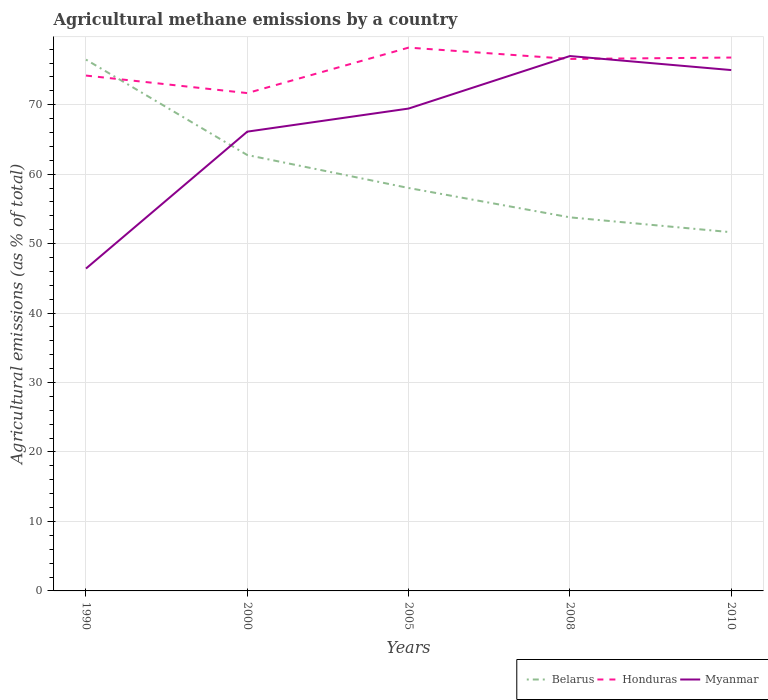Does the line corresponding to Honduras intersect with the line corresponding to Myanmar?
Provide a succinct answer. Yes. Is the number of lines equal to the number of legend labels?
Provide a short and direct response. Yes. Across all years, what is the maximum amount of agricultural methane emitted in Belarus?
Your answer should be very brief. 51.64. What is the total amount of agricultural methane emitted in Honduras in the graph?
Your answer should be very brief. 1.63. What is the difference between the highest and the second highest amount of agricultural methane emitted in Myanmar?
Your answer should be compact. 30.59. What is the difference between the highest and the lowest amount of agricultural methane emitted in Myanmar?
Your answer should be very brief. 3. Is the amount of agricultural methane emitted in Myanmar strictly greater than the amount of agricultural methane emitted in Belarus over the years?
Ensure brevity in your answer.  No. What is the difference between two consecutive major ticks on the Y-axis?
Make the answer very short. 10. Are the values on the major ticks of Y-axis written in scientific E-notation?
Provide a short and direct response. No. Does the graph contain any zero values?
Ensure brevity in your answer.  No. Does the graph contain grids?
Your response must be concise. Yes. How many legend labels are there?
Keep it short and to the point. 3. What is the title of the graph?
Keep it short and to the point. Agricultural methane emissions by a country. Does "Antigua and Barbuda" appear as one of the legend labels in the graph?
Keep it short and to the point. No. What is the label or title of the Y-axis?
Your answer should be very brief. Agricultural emissions (as % of total). What is the Agricultural emissions (as % of total) of Belarus in 1990?
Ensure brevity in your answer.  76.49. What is the Agricultural emissions (as % of total) in Honduras in 1990?
Make the answer very short. 74.19. What is the Agricultural emissions (as % of total) of Myanmar in 1990?
Give a very brief answer. 46.41. What is the Agricultural emissions (as % of total) in Belarus in 2000?
Your answer should be compact. 62.75. What is the Agricultural emissions (as % of total) in Honduras in 2000?
Give a very brief answer. 71.67. What is the Agricultural emissions (as % of total) of Myanmar in 2000?
Your answer should be very brief. 66.12. What is the Agricultural emissions (as % of total) in Belarus in 2005?
Offer a very short reply. 58.01. What is the Agricultural emissions (as % of total) of Honduras in 2005?
Your response must be concise. 78.21. What is the Agricultural emissions (as % of total) in Myanmar in 2005?
Provide a succinct answer. 69.44. What is the Agricultural emissions (as % of total) of Belarus in 2008?
Give a very brief answer. 53.78. What is the Agricultural emissions (as % of total) of Honduras in 2008?
Your answer should be compact. 76.58. What is the Agricultural emissions (as % of total) in Myanmar in 2008?
Ensure brevity in your answer.  77. What is the Agricultural emissions (as % of total) of Belarus in 2010?
Offer a very short reply. 51.64. What is the Agricultural emissions (as % of total) of Honduras in 2010?
Offer a terse response. 76.78. What is the Agricultural emissions (as % of total) in Myanmar in 2010?
Provide a succinct answer. 74.98. Across all years, what is the maximum Agricultural emissions (as % of total) of Belarus?
Offer a terse response. 76.49. Across all years, what is the maximum Agricultural emissions (as % of total) of Honduras?
Your response must be concise. 78.21. Across all years, what is the maximum Agricultural emissions (as % of total) in Myanmar?
Provide a succinct answer. 77. Across all years, what is the minimum Agricultural emissions (as % of total) of Belarus?
Your response must be concise. 51.64. Across all years, what is the minimum Agricultural emissions (as % of total) of Honduras?
Give a very brief answer. 71.67. Across all years, what is the minimum Agricultural emissions (as % of total) of Myanmar?
Your answer should be very brief. 46.41. What is the total Agricultural emissions (as % of total) in Belarus in the graph?
Your answer should be compact. 302.66. What is the total Agricultural emissions (as % of total) of Honduras in the graph?
Your answer should be compact. 377.44. What is the total Agricultural emissions (as % of total) of Myanmar in the graph?
Give a very brief answer. 333.95. What is the difference between the Agricultural emissions (as % of total) of Belarus in 1990 and that in 2000?
Offer a terse response. 13.74. What is the difference between the Agricultural emissions (as % of total) of Honduras in 1990 and that in 2000?
Ensure brevity in your answer.  2.52. What is the difference between the Agricultural emissions (as % of total) of Myanmar in 1990 and that in 2000?
Your response must be concise. -19.71. What is the difference between the Agricultural emissions (as % of total) in Belarus in 1990 and that in 2005?
Keep it short and to the point. 18.48. What is the difference between the Agricultural emissions (as % of total) in Honduras in 1990 and that in 2005?
Keep it short and to the point. -4.02. What is the difference between the Agricultural emissions (as % of total) of Myanmar in 1990 and that in 2005?
Provide a succinct answer. -23.03. What is the difference between the Agricultural emissions (as % of total) of Belarus in 1990 and that in 2008?
Ensure brevity in your answer.  22.71. What is the difference between the Agricultural emissions (as % of total) of Honduras in 1990 and that in 2008?
Offer a very short reply. -2.39. What is the difference between the Agricultural emissions (as % of total) of Myanmar in 1990 and that in 2008?
Your answer should be very brief. -30.59. What is the difference between the Agricultural emissions (as % of total) in Belarus in 1990 and that in 2010?
Keep it short and to the point. 24.85. What is the difference between the Agricultural emissions (as % of total) of Honduras in 1990 and that in 2010?
Your answer should be very brief. -2.59. What is the difference between the Agricultural emissions (as % of total) of Myanmar in 1990 and that in 2010?
Offer a very short reply. -28.57. What is the difference between the Agricultural emissions (as % of total) of Belarus in 2000 and that in 2005?
Your response must be concise. 4.74. What is the difference between the Agricultural emissions (as % of total) of Honduras in 2000 and that in 2005?
Provide a succinct answer. -6.55. What is the difference between the Agricultural emissions (as % of total) of Myanmar in 2000 and that in 2005?
Ensure brevity in your answer.  -3.32. What is the difference between the Agricultural emissions (as % of total) in Belarus in 2000 and that in 2008?
Provide a short and direct response. 8.97. What is the difference between the Agricultural emissions (as % of total) in Honduras in 2000 and that in 2008?
Your response must be concise. -4.92. What is the difference between the Agricultural emissions (as % of total) in Myanmar in 2000 and that in 2008?
Your answer should be very brief. -10.88. What is the difference between the Agricultural emissions (as % of total) of Belarus in 2000 and that in 2010?
Give a very brief answer. 11.11. What is the difference between the Agricultural emissions (as % of total) of Honduras in 2000 and that in 2010?
Make the answer very short. -5.12. What is the difference between the Agricultural emissions (as % of total) of Myanmar in 2000 and that in 2010?
Make the answer very short. -8.86. What is the difference between the Agricultural emissions (as % of total) in Belarus in 2005 and that in 2008?
Your answer should be compact. 4.23. What is the difference between the Agricultural emissions (as % of total) of Honduras in 2005 and that in 2008?
Keep it short and to the point. 1.63. What is the difference between the Agricultural emissions (as % of total) in Myanmar in 2005 and that in 2008?
Provide a succinct answer. -7.56. What is the difference between the Agricultural emissions (as % of total) of Belarus in 2005 and that in 2010?
Ensure brevity in your answer.  6.37. What is the difference between the Agricultural emissions (as % of total) of Honduras in 2005 and that in 2010?
Provide a short and direct response. 1.43. What is the difference between the Agricultural emissions (as % of total) of Myanmar in 2005 and that in 2010?
Offer a terse response. -5.54. What is the difference between the Agricultural emissions (as % of total) in Belarus in 2008 and that in 2010?
Ensure brevity in your answer.  2.14. What is the difference between the Agricultural emissions (as % of total) of Honduras in 2008 and that in 2010?
Offer a very short reply. -0.2. What is the difference between the Agricultural emissions (as % of total) of Myanmar in 2008 and that in 2010?
Offer a terse response. 2.02. What is the difference between the Agricultural emissions (as % of total) in Belarus in 1990 and the Agricultural emissions (as % of total) in Honduras in 2000?
Keep it short and to the point. 4.82. What is the difference between the Agricultural emissions (as % of total) in Belarus in 1990 and the Agricultural emissions (as % of total) in Myanmar in 2000?
Provide a short and direct response. 10.37. What is the difference between the Agricultural emissions (as % of total) in Honduras in 1990 and the Agricultural emissions (as % of total) in Myanmar in 2000?
Make the answer very short. 8.07. What is the difference between the Agricultural emissions (as % of total) of Belarus in 1990 and the Agricultural emissions (as % of total) of Honduras in 2005?
Make the answer very short. -1.73. What is the difference between the Agricultural emissions (as % of total) in Belarus in 1990 and the Agricultural emissions (as % of total) in Myanmar in 2005?
Offer a very short reply. 7.05. What is the difference between the Agricultural emissions (as % of total) of Honduras in 1990 and the Agricultural emissions (as % of total) of Myanmar in 2005?
Offer a terse response. 4.75. What is the difference between the Agricultural emissions (as % of total) of Belarus in 1990 and the Agricultural emissions (as % of total) of Honduras in 2008?
Provide a succinct answer. -0.1. What is the difference between the Agricultural emissions (as % of total) in Belarus in 1990 and the Agricultural emissions (as % of total) in Myanmar in 2008?
Ensure brevity in your answer.  -0.51. What is the difference between the Agricultural emissions (as % of total) of Honduras in 1990 and the Agricultural emissions (as % of total) of Myanmar in 2008?
Make the answer very short. -2.81. What is the difference between the Agricultural emissions (as % of total) in Belarus in 1990 and the Agricultural emissions (as % of total) in Honduras in 2010?
Give a very brief answer. -0.3. What is the difference between the Agricultural emissions (as % of total) of Belarus in 1990 and the Agricultural emissions (as % of total) of Myanmar in 2010?
Keep it short and to the point. 1.5. What is the difference between the Agricultural emissions (as % of total) of Honduras in 1990 and the Agricultural emissions (as % of total) of Myanmar in 2010?
Provide a short and direct response. -0.79. What is the difference between the Agricultural emissions (as % of total) in Belarus in 2000 and the Agricultural emissions (as % of total) in Honduras in 2005?
Keep it short and to the point. -15.46. What is the difference between the Agricultural emissions (as % of total) of Belarus in 2000 and the Agricultural emissions (as % of total) of Myanmar in 2005?
Your answer should be compact. -6.69. What is the difference between the Agricultural emissions (as % of total) in Honduras in 2000 and the Agricultural emissions (as % of total) in Myanmar in 2005?
Your answer should be very brief. 2.23. What is the difference between the Agricultural emissions (as % of total) in Belarus in 2000 and the Agricultural emissions (as % of total) in Honduras in 2008?
Your response must be concise. -13.83. What is the difference between the Agricultural emissions (as % of total) in Belarus in 2000 and the Agricultural emissions (as % of total) in Myanmar in 2008?
Offer a very short reply. -14.25. What is the difference between the Agricultural emissions (as % of total) of Honduras in 2000 and the Agricultural emissions (as % of total) of Myanmar in 2008?
Ensure brevity in your answer.  -5.33. What is the difference between the Agricultural emissions (as % of total) in Belarus in 2000 and the Agricultural emissions (as % of total) in Honduras in 2010?
Your answer should be compact. -14.03. What is the difference between the Agricultural emissions (as % of total) of Belarus in 2000 and the Agricultural emissions (as % of total) of Myanmar in 2010?
Provide a short and direct response. -12.23. What is the difference between the Agricultural emissions (as % of total) in Honduras in 2000 and the Agricultural emissions (as % of total) in Myanmar in 2010?
Keep it short and to the point. -3.31. What is the difference between the Agricultural emissions (as % of total) in Belarus in 2005 and the Agricultural emissions (as % of total) in Honduras in 2008?
Make the answer very short. -18.58. What is the difference between the Agricultural emissions (as % of total) of Belarus in 2005 and the Agricultural emissions (as % of total) of Myanmar in 2008?
Your response must be concise. -19. What is the difference between the Agricultural emissions (as % of total) in Honduras in 2005 and the Agricultural emissions (as % of total) in Myanmar in 2008?
Your answer should be very brief. 1.21. What is the difference between the Agricultural emissions (as % of total) of Belarus in 2005 and the Agricultural emissions (as % of total) of Honduras in 2010?
Offer a terse response. -18.78. What is the difference between the Agricultural emissions (as % of total) in Belarus in 2005 and the Agricultural emissions (as % of total) in Myanmar in 2010?
Offer a very short reply. -16.98. What is the difference between the Agricultural emissions (as % of total) of Honduras in 2005 and the Agricultural emissions (as % of total) of Myanmar in 2010?
Give a very brief answer. 3.23. What is the difference between the Agricultural emissions (as % of total) in Belarus in 2008 and the Agricultural emissions (as % of total) in Honduras in 2010?
Make the answer very short. -23. What is the difference between the Agricultural emissions (as % of total) of Belarus in 2008 and the Agricultural emissions (as % of total) of Myanmar in 2010?
Your response must be concise. -21.2. What is the difference between the Agricultural emissions (as % of total) of Honduras in 2008 and the Agricultural emissions (as % of total) of Myanmar in 2010?
Make the answer very short. 1.6. What is the average Agricultural emissions (as % of total) in Belarus per year?
Provide a short and direct response. 60.53. What is the average Agricultural emissions (as % of total) of Honduras per year?
Ensure brevity in your answer.  75.49. What is the average Agricultural emissions (as % of total) in Myanmar per year?
Provide a succinct answer. 66.79. In the year 1990, what is the difference between the Agricultural emissions (as % of total) in Belarus and Agricultural emissions (as % of total) in Honduras?
Ensure brevity in your answer.  2.29. In the year 1990, what is the difference between the Agricultural emissions (as % of total) in Belarus and Agricultural emissions (as % of total) in Myanmar?
Give a very brief answer. 30.08. In the year 1990, what is the difference between the Agricultural emissions (as % of total) in Honduras and Agricultural emissions (as % of total) in Myanmar?
Give a very brief answer. 27.79. In the year 2000, what is the difference between the Agricultural emissions (as % of total) of Belarus and Agricultural emissions (as % of total) of Honduras?
Your answer should be compact. -8.92. In the year 2000, what is the difference between the Agricultural emissions (as % of total) in Belarus and Agricultural emissions (as % of total) in Myanmar?
Offer a terse response. -3.37. In the year 2000, what is the difference between the Agricultural emissions (as % of total) in Honduras and Agricultural emissions (as % of total) in Myanmar?
Keep it short and to the point. 5.55. In the year 2005, what is the difference between the Agricultural emissions (as % of total) of Belarus and Agricultural emissions (as % of total) of Honduras?
Offer a very short reply. -20.21. In the year 2005, what is the difference between the Agricultural emissions (as % of total) of Belarus and Agricultural emissions (as % of total) of Myanmar?
Offer a very short reply. -11.44. In the year 2005, what is the difference between the Agricultural emissions (as % of total) in Honduras and Agricultural emissions (as % of total) in Myanmar?
Offer a very short reply. 8.77. In the year 2008, what is the difference between the Agricultural emissions (as % of total) in Belarus and Agricultural emissions (as % of total) in Honduras?
Offer a very short reply. -22.8. In the year 2008, what is the difference between the Agricultural emissions (as % of total) of Belarus and Agricultural emissions (as % of total) of Myanmar?
Your answer should be compact. -23.22. In the year 2008, what is the difference between the Agricultural emissions (as % of total) of Honduras and Agricultural emissions (as % of total) of Myanmar?
Your answer should be very brief. -0.42. In the year 2010, what is the difference between the Agricultural emissions (as % of total) of Belarus and Agricultural emissions (as % of total) of Honduras?
Provide a short and direct response. -25.14. In the year 2010, what is the difference between the Agricultural emissions (as % of total) in Belarus and Agricultural emissions (as % of total) in Myanmar?
Offer a terse response. -23.34. In the year 2010, what is the difference between the Agricultural emissions (as % of total) in Honduras and Agricultural emissions (as % of total) in Myanmar?
Provide a short and direct response. 1.8. What is the ratio of the Agricultural emissions (as % of total) of Belarus in 1990 to that in 2000?
Your answer should be compact. 1.22. What is the ratio of the Agricultural emissions (as % of total) in Honduras in 1990 to that in 2000?
Offer a terse response. 1.04. What is the ratio of the Agricultural emissions (as % of total) in Myanmar in 1990 to that in 2000?
Offer a terse response. 0.7. What is the ratio of the Agricultural emissions (as % of total) of Belarus in 1990 to that in 2005?
Offer a very short reply. 1.32. What is the ratio of the Agricultural emissions (as % of total) of Honduras in 1990 to that in 2005?
Your response must be concise. 0.95. What is the ratio of the Agricultural emissions (as % of total) in Myanmar in 1990 to that in 2005?
Provide a succinct answer. 0.67. What is the ratio of the Agricultural emissions (as % of total) in Belarus in 1990 to that in 2008?
Offer a terse response. 1.42. What is the ratio of the Agricultural emissions (as % of total) of Honduras in 1990 to that in 2008?
Your answer should be compact. 0.97. What is the ratio of the Agricultural emissions (as % of total) in Myanmar in 1990 to that in 2008?
Offer a terse response. 0.6. What is the ratio of the Agricultural emissions (as % of total) of Belarus in 1990 to that in 2010?
Your answer should be compact. 1.48. What is the ratio of the Agricultural emissions (as % of total) in Honduras in 1990 to that in 2010?
Offer a terse response. 0.97. What is the ratio of the Agricultural emissions (as % of total) in Myanmar in 1990 to that in 2010?
Ensure brevity in your answer.  0.62. What is the ratio of the Agricultural emissions (as % of total) in Belarus in 2000 to that in 2005?
Ensure brevity in your answer.  1.08. What is the ratio of the Agricultural emissions (as % of total) of Honduras in 2000 to that in 2005?
Your answer should be compact. 0.92. What is the ratio of the Agricultural emissions (as % of total) of Myanmar in 2000 to that in 2005?
Provide a succinct answer. 0.95. What is the ratio of the Agricultural emissions (as % of total) of Belarus in 2000 to that in 2008?
Ensure brevity in your answer.  1.17. What is the ratio of the Agricultural emissions (as % of total) in Honduras in 2000 to that in 2008?
Provide a succinct answer. 0.94. What is the ratio of the Agricultural emissions (as % of total) of Myanmar in 2000 to that in 2008?
Your answer should be compact. 0.86. What is the ratio of the Agricultural emissions (as % of total) in Belarus in 2000 to that in 2010?
Ensure brevity in your answer.  1.22. What is the ratio of the Agricultural emissions (as % of total) of Honduras in 2000 to that in 2010?
Provide a short and direct response. 0.93. What is the ratio of the Agricultural emissions (as % of total) of Myanmar in 2000 to that in 2010?
Ensure brevity in your answer.  0.88. What is the ratio of the Agricultural emissions (as % of total) of Belarus in 2005 to that in 2008?
Keep it short and to the point. 1.08. What is the ratio of the Agricultural emissions (as % of total) of Honduras in 2005 to that in 2008?
Keep it short and to the point. 1.02. What is the ratio of the Agricultural emissions (as % of total) in Myanmar in 2005 to that in 2008?
Ensure brevity in your answer.  0.9. What is the ratio of the Agricultural emissions (as % of total) in Belarus in 2005 to that in 2010?
Provide a short and direct response. 1.12. What is the ratio of the Agricultural emissions (as % of total) in Honduras in 2005 to that in 2010?
Make the answer very short. 1.02. What is the ratio of the Agricultural emissions (as % of total) in Myanmar in 2005 to that in 2010?
Your answer should be compact. 0.93. What is the ratio of the Agricultural emissions (as % of total) of Belarus in 2008 to that in 2010?
Your answer should be very brief. 1.04. What is the ratio of the Agricultural emissions (as % of total) in Honduras in 2008 to that in 2010?
Your response must be concise. 1. What is the ratio of the Agricultural emissions (as % of total) of Myanmar in 2008 to that in 2010?
Provide a short and direct response. 1.03. What is the difference between the highest and the second highest Agricultural emissions (as % of total) in Belarus?
Ensure brevity in your answer.  13.74. What is the difference between the highest and the second highest Agricultural emissions (as % of total) in Honduras?
Keep it short and to the point. 1.43. What is the difference between the highest and the second highest Agricultural emissions (as % of total) in Myanmar?
Your answer should be very brief. 2.02. What is the difference between the highest and the lowest Agricultural emissions (as % of total) in Belarus?
Your response must be concise. 24.85. What is the difference between the highest and the lowest Agricultural emissions (as % of total) of Honduras?
Your answer should be compact. 6.55. What is the difference between the highest and the lowest Agricultural emissions (as % of total) in Myanmar?
Keep it short and to the point. 30.59. 